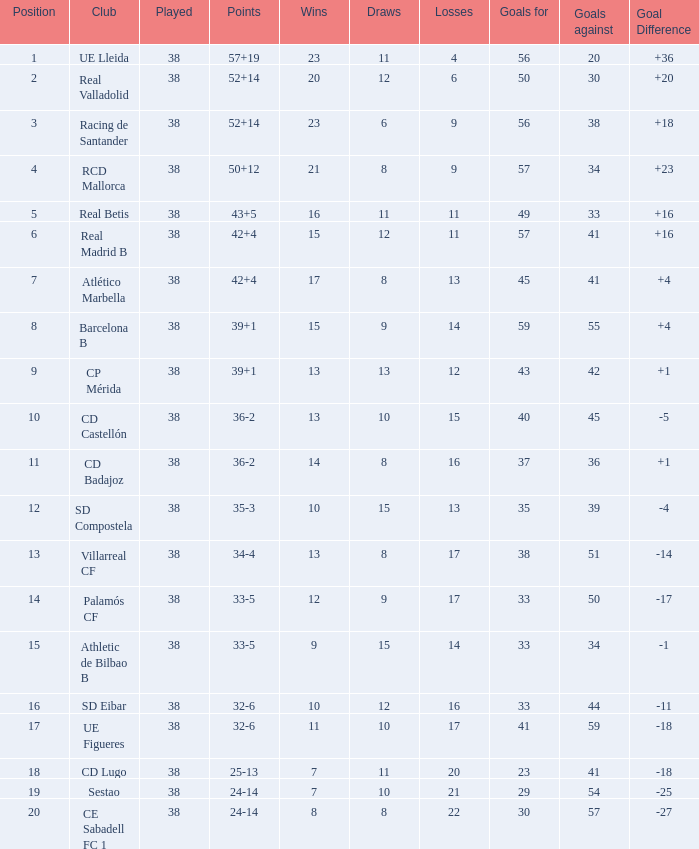What is the greatest number reached with a goal difference lesser than -27? None. 